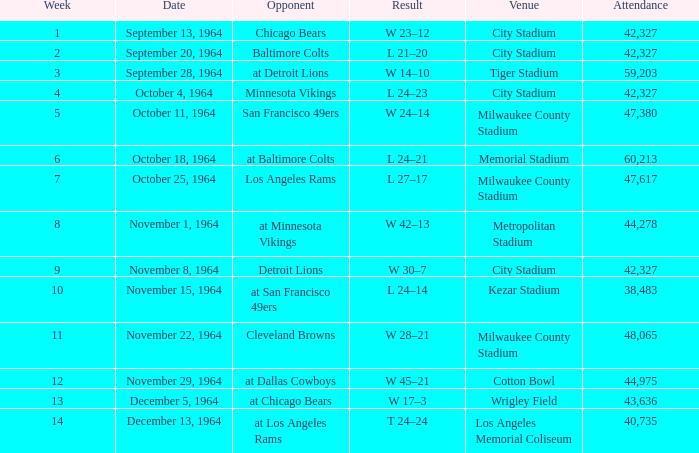For the game held on november 22, 1964, with 48,065 spectators, which average week was it? None. 